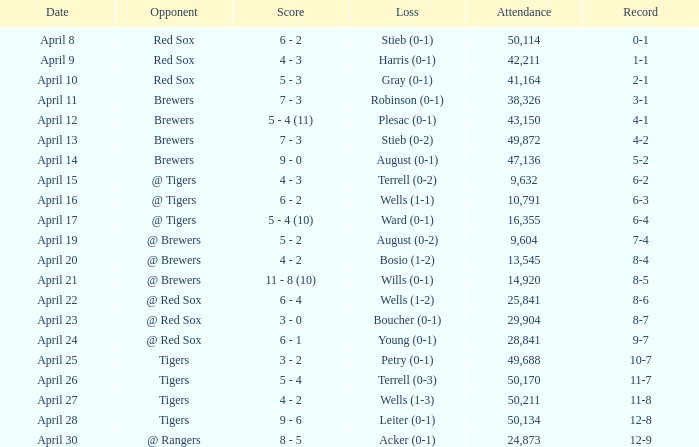Which competitor has a record of 11-8 and an attendance exceeding 29,904? Tigers. 